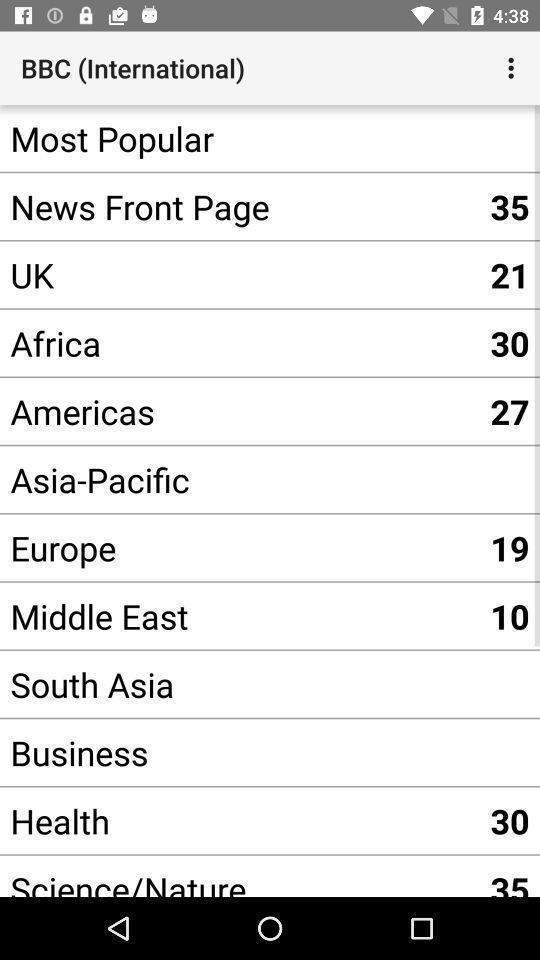Summarize the main components in this picture. Window displaying news reader app. 